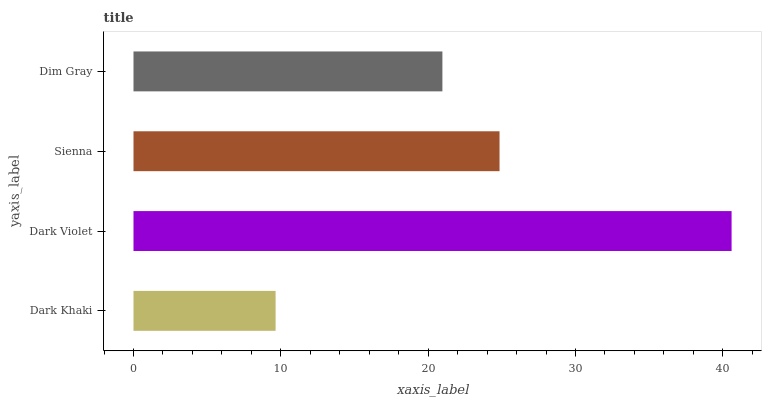Is Dark Khaki the minimum?
Answer yes or no. Yes. Is Dark Violet the maximum?
Answer yes or no. Yes. Is Sienna the minimum?
Answer yes or no. No. Is Sienna the maximum?
Answer yes or no. No. Is Dark Violet greater than Sienna?
Answer yes or no. Yes. Is Sienna less than Dark Violet?
Answer yes or no. Yes. Is Sienna greater than Dark Violet?
Answer yes or no. No. Is Dark Violet less than Sienna?
Answer yes or no. No. Is Sienna the high median?
Answer yes or no. Yes. Is Dim Gray the low median?
Answer yes or no. Yes. Is Dark Violet the high median?
Answer yes or no. No. Is Sienna the low median?
Answer yes or no. No. 